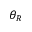Convert formula to latex. <formula><loc_0><loc_0><loc_500><loc_500>\theta _ { R }</formula> 